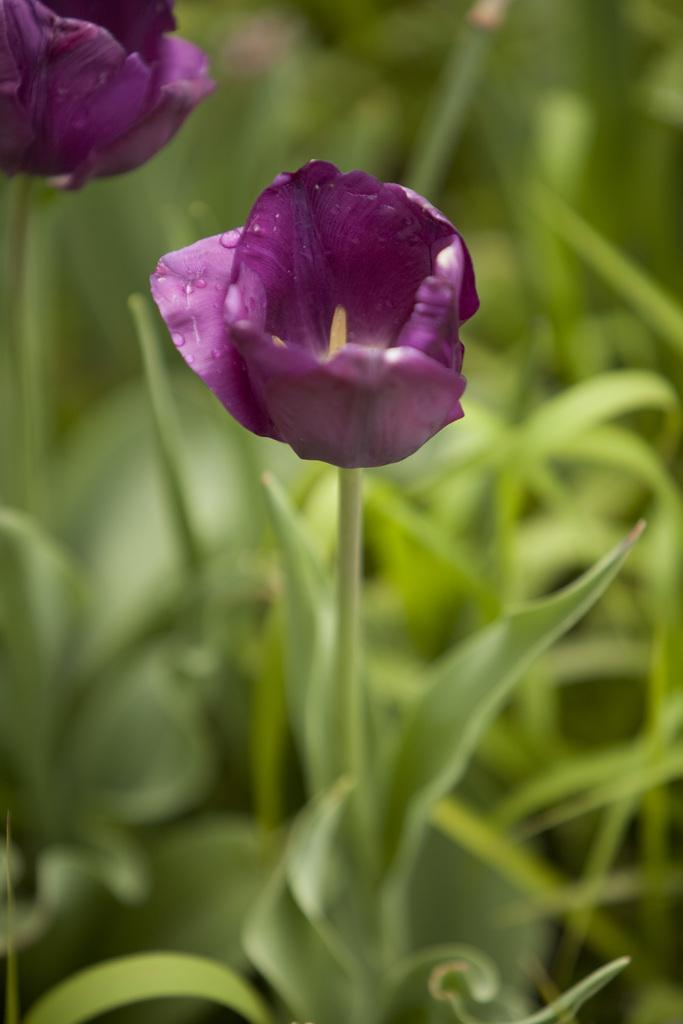What type of flowers can be seen in the image? There are two violet flowers in the image. What color are the plants in the background of the image? The plants in the background of the image are green. How would you describe the background of the image? The background of the image is blurry. What type of feather can be seen in the image? There is no feather present in the image. What type of jam is being served with the flowers in the image? There is no jam in the image; it only features flowers and plants. 